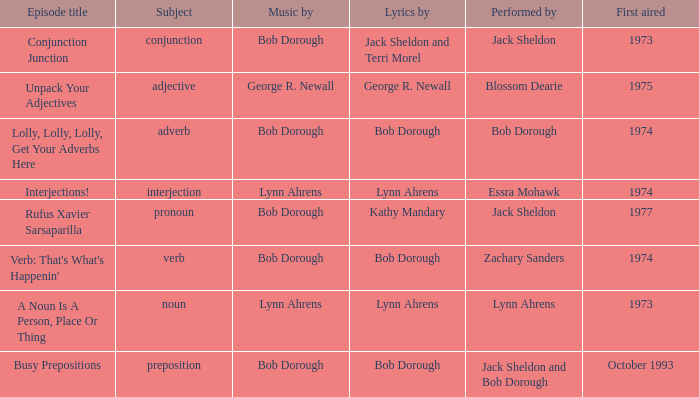With zachary sanders as the artist, how many people is the music composed by? 1.0. 